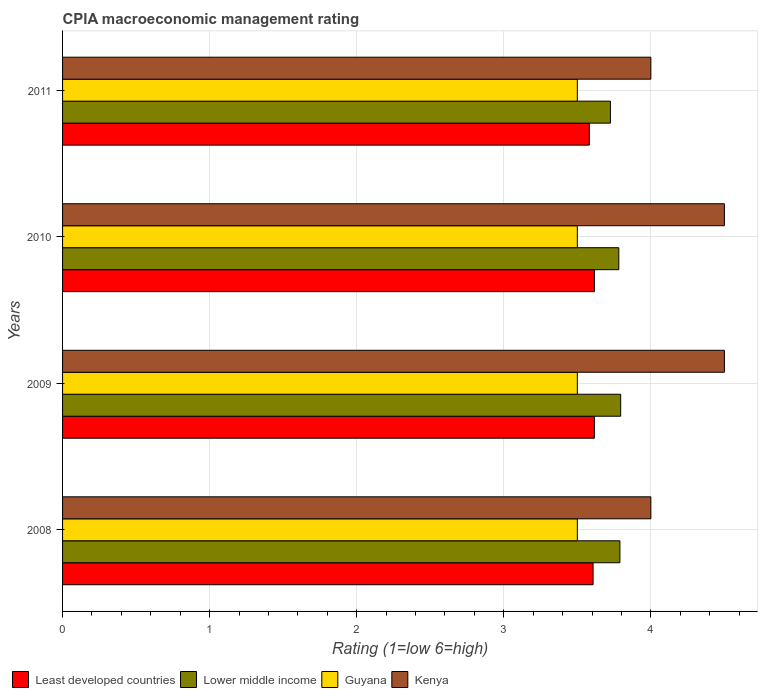Are the number of bars on each tick of the Y-axis equal?
Keep it short and to the point. Yes. How many bars are there on the 1st tick from the top?
Offer a very short reply. 4. How many bars are there on the 3rd tick from the bottom?
Your response must be concise. 4. In how many cases, is the number of bars for a given year not equal to the number of legend labels?
Make the answer very short. 0. What is the CPIA rating in Guyana in 2008?
Provide a short and direct response. 3.5. Across all years, what is the maximum CPIA rating in Lower middle income?
Your response must be concise. 3.79. Across all years, what is the minimum CPIA rating in Lower middle income?
Give a very brief answer. 3.73. In which year was the CPIA rating in Lower middle income minimum?
Your response must be concise. 2011. What is the difference between the CPIA rating in Lower middle income in 2009 and that in 2011?
Make the answer very short. 0.07. What is the difference between the CPIA rating in Least developed countries in 2009 and the CPIA rating in Lower middle income in 2008?
Offer a very short reply. -0.17. What is the average CPIA rating in Least developed countries per year?
Offer a very short reply. 3.61. In the year 2008, what is the difference between the CPIA rating in Guyana and CPIA rating in Least developed countries?
Your answer should be compact. -0.11. What is the ratio of the CPIA rating in Least developed countries in 2008 to that in 2011?
Your answer should be compact. 1.01. What is the difference between the highest and the second highest CPIA rating in Lower middle income?
Your answer should be very brief. 0.01. What is the difference between the highest and the lowest CPIA rating in Kenya?
Make the answer very short. 0.5. Is the sum of the CPIA rating in Kenya in 2009 and 2010 greater than the maximum CPIA rating in Guyana across all years?
Provide a succinct answer. Yes. Is it the case that in every year, the sum of the CPIA rating in Lower middle income and CPIA rating in Least developed countries is greater than the sum of CPIA rating in Kenya and CPIA rating in Guyana?
Make the answer very short. Yes. What does the 4th bar from the top in 2009 represents?
Your answer should be very brief. Least developed countries. What does the 1st bar from the bottom in 2008 represents?
Your answer should be very brief. Least developed countries. How many bars are there?
Keep it short and to the point. 16. What is the difference between two consecutive major ticks on the X-axis?
Your answer should be compact. 1. How many legend labels are there?
Make the answer very short. 4. How are the legend labels stacked?
Offer a terse response. Horizontal. What is the title of the graph?
Keep it short and to the point. CPIA macroeconomic management rating. What is the label or title of the X-axis?
Your answer should be very brief. Rating (1=low 6=high). What is the label or title of the Y-axis?
Your response must be concise. Years. What is the Rating (1=low 6=high) in Least developed countries in 2008?
Give a very brief answer. 3.61. What is the Rating (1=low 6=high) in Lower middle income in 2008?
Provide a short and direct response. 3.79. What is the Rating (1=low 6=high) of Least developed countries in 2009?
Keep it short and to the point. 3.62. What is the Rating (1=low 6=high) of Lower middle income in 2009?
Offer a very short reply. 3.79. What is the Rating (1=low 6=high) in Guyana in 2009?
Ensure brevity in your answer.  3.5. What is the Rating (1=low 6=high) in Least developed countries in 2010?
Give a very brief answer. 3.62. What is the Rating (1=low 6=high) in Lower middle income in 2010?
Your answer should be very brief. 3.78. What is the Rating (1=low 6=high) in Guyana in 2010?
Your answer should be very brief. 3.5. What is the Rating (1=low 6=high) of Kenya in 2010?
Offer a terse response. 4.5. What is the Rating (1=low 6=high) in Least developed countries in 2011?
Make the answer very short. 3.58. What is the Rating (1=low 6=high) of Lower middle income in 2011?
Make the answer very short. 3.73. What is the Rating (1=low 6=high) of Guyana in 2011?
Ensure brevity in your answer.  3.5. What is the Rating (1=low 6=high) of Kenya in 2011?
Make the answer very short. 4. Across all years, what is the maximum Rating (1=low 6=high) in Least developed countries?
Keep it short and to the point. 3.62. Across all years, what is the maximum Rating (1=low 6=high) of Lower middle income?
Provide a succinct answer. 3.79. Across all years, what is the maximum Rating (1=low 6=high) of Guyana?
Provide a short and direct response. 3.5. Across all years, what is the minimum Rating (1=low 6=high) of Least developed countries?
Offer a very short reply. 3.58. Across all years, what is the minimum Rating (1=low 6=high) in Lower middle income?
Your answer should be compact. 3.73. What is the total Rating (1=low 6=high) of Least developed countries in the graph?
Make the answer very short. 14.42. What is the total Rating (1=low 6=high) of Lower middle income in the graph?
Provide a succinct answer. 15.09. What is the difference between the Rating (1=low 6=high) in Least developed countries in 2008 and that in 2009?
Ensure brevity in your answer.  -0.01. What is the difference between the Rating (1=low 6=high) in Lower middle income in 2008 and that in 2009?
Your answer should be compact. -0.01. What is the difference between the Rating (1=low 6=high) of Guyana in 2008 and that in 2009?
Your answer should be compact. 0. What is the difference between the Rating (1=low 6=high) in Kenya in 2008 and that in 2009?
Give a very brief answer. -0.5. What is the difference between the Rating (1=low 6=high) in Least developed countries in 2008 and that in 2010?
Offer a terse response. -0.01. What is the difference between the Rating (1=low 6=high) of Lower middle income in 2008 and that in 2010?
Provide a short and direct response. 0.01. What is the difference between the Rating (1=low 6=high) of Least developed countries in 2008 and that in 2011?
Offer a terse response. 0.03. What is the difference between the Rating (1=low 6=high) of Lower middle income in 2008 and that in 2011?
Provide a succinct answer. 0.06. What is the difference between the Rating (1=low 6=high) of Least developed countries in 2009 and that in 2010?
Your response must be concise. 0. What is the difference between the Rating (1=low 6=high) of Lower middle income in 2009 and that in 2010?
Offer a very short reply. 0.01. What is the difference between the Rating (1=low 6=high) of Guyana in 2009 and that in 2010?
Ensure brevity in your answer.  0. What is the difference between the Rating (1=low 6=high) of Least developed countries in 2009 and that in 2011?
Your response must be concise. 0.03. What is the difference between the Rating (1=low 6=high) of Lower middle income in 2009 and that in 2011?
Give a very brief answer. 0.07. What is the difference between the Rating (1=low 6=high) of Guyana in 2009 and that in 2011?
Your answer should be very brief. 0. What is the difference between the Rating (1=low 6=high) of Kenya in 2009 and that in 2011?
Provide a short and direct response. 0.5. What is the difference between the Rating (1=low 6=high) in Least developed countries in 2010 and that in 2011?
Provide a succinct answer. 0.03. What is the difference between the Rating (1=low 6=high) of Lower middle income in 2010 and that in 2011?
Your answer should be very brief. 0.06. What is the difference between the Rating (1=low 6=high) of Kenya in 2010 and that in 2011?
Give a very brief answer. 0.5. What is the difference between the Rating (1=low 6=high) in Least developed countries in 2008 and the Rating (1=low 6=high) in Lower middle income in 2009?
Your answer should be very brief. -0.19. What is the difference between the Rating (1=low 6=high) of Least developed countries in 2008 and the Rating (1=low 6=high) of Guyana in 2009?
Your response must be concise. 0.11. What is the difference between the Rating (1=low 6=high) in Least developed countries in 2008 and the Rating (1=low 6=high) in Kenya in 2009?
Offer a terse response. -0.89. What is the difference between the Rating (1=low 6=high) in Lower middle income in 2008 and the Rating (1=low 6=high) in Guyana in 2009?
Your response must be concise. 0.29. What is the difference between the Rating (1=low 6=high) of Lower middle income in 2008 and the Rating (1=low 6=high) of Kenya in 2009?
Your answer should be compact. -0.71. What is the difference between the Rating (1=low 6=high) of Guyana in 2008 and the Rating (1=low 6=high) of Kenya in 2009?
Your response must be concise. -1. What is the difference between the Rating (1=low 6=high) of Least developed countries in 2008 and the Rating (1=low 6=high) of Lower middle income in 2010?
Give a very brief answer. -0.17. What is the difference between the Rating (1=low 6=high) of Least developed countries in 2008 and the Rating (1=low 6=high) of Guyana in 2010?
Offer a terse response. 0.11. What is the difference between the Rating (1=low 6=high) of Least developed countries in 2008 and the Rating (1=low 6=high) of Kenya in 2010?
Keep it short and to the point. -0.89. What is the difference between the Rating (1=low 6=high) of Lower middle income in 2008 and the Rating (1=low 6=high) of Guyana in 2010?
Keep it short and to the point. 0.29. What is the difference between the Rating (1=low 6=high) of Lower middle income in 2008 and the Rating (1=low 6=high) of Kenya in 2010?
Your response must be concise. -0.71. What is the difference between the Rating (1=low 6=high) of Guyana in 2008 and the Rating (1=low 6=high) of Kenya in 2010?
Your answer should be compact. -1. What is the difference between the Rating (1=low 6=high) of Least developed countries in 2008 and the Rating (1=low 6=high) of Lower middle income in 2011?
Provide a short and direct response. -0.12. What is the difference between the Rating (1=low 6=high) of Least developed countries in 2008 and the Rating (1=low 6=high) of Guyana in 2011?
Provide a short and direct response. 0.11. What is the difference between the Rating (1=low 6=high) in Least developed countries in 2008 and the Rating (1=low 6=high) in Kenya in 2011?
Offer a terse response. -0.39. What is the difference between the Rating (1=low 6=high) in Lower middle income in 2008 and the Rating (1=low 6=high) in Guyana in 2011?
Your response must be concise. 0.29. What is the difference between the Rating (1=low 6=high) of Lower middle income in 2008 and the Rating (1=low 6=high) of Kenya in 2011?
Ensure brevity in your answer.  -0.21. What is the difference between the Rating (1=low 6=high) of Least developed countries in 2009 and the Rating (1=low 6=high) of Lower middle income in 2010?
Your answer should be compact. -0.17. What is the difference between the Rating (1=low 6=high) in Least developed countries in 2009 and the Rating (1=low 6=high) in Guyana in 2010?
Ensure brevity in your answer.  0.12. What is the difference between the Rating (1=low 6=high) in Least developed countries in 2009 and the Rating (1=low 6=high) in Kenya in 2010?
Make the answer very short. -0.88. What is the difference between the Rating (1=low 6=high) of Lower middle income in 2009 and the Rating (1=low 6=high) of Guyana in 2010?
Give a very brief answer. 0.29. What is the difference between the Rating (1=low 6=high) of Lower middle income in 2009 and the Rating (1=low 6=high) of Kenya in 2010?
Keep it short and to the point. -0.71. What is the difference between the Rating (1=low 6=high) in Least developed countries in 2009 and the Rating (1=low 6=high) in Lower middle income in 2011?
Provide a short and direct response. -0.11. What is the difference between the Rating (1=low 6=high) of Least developed countries in 2009 and the Rating (1=low 6=high) of Guyana in 2011?
Offer a very short reply. 0.12. What is the difference between the Rating (1=low 6=high) of Least developed countries in 2009 and the Rating (1=low 6=high) of Kenya in 2011?
Your response must be concise. -0.38. What is the difference between the Rating (1=low 6=high) of Lower middle income in 2009 and the Rating (1=low 6=high) of Guyana in 2011?
Offer a very short reply. 0.29. What is the difference between the Rating (1=low 6=high) in Lower middle income in 2009 and the Rating (1=low 6=high) in Kenya in 2011?
Make the answer very short. -0.21. What is the difference between the Rating (1=low 6=high) in Guyana in 2009 and the Rating (1=low 6=high) in Kenya in 2011?
Your response must be concise. -0.5. What is the difference between the Rating (1=low 6=high) in Least developed countries in 2010 and the Rating (1=low 6=high) in Lower middle income in 2011?
Provide a succinct answer. -0.11. What is the difference between the Rating (1=low 6=high) of Least developed countries in 2010 and the Rating (1=low 6=high) of Guyana in 2011?
Offer a very short reply. 0.12. What is the difference between the Rating (1=low 6=high) in Least developed countries in 2010 and the Rating (1=low 6=high) in Kenya in 2011?
Provide a short and direct response. -0.38. What is the difference between the Rating (1=low 6=high) in Lower middle income in 2010 and the Rating (1=low 6=high) in Guyana in 2011?
Keep it short and to the point. 0.28. What is the difference between the Rating (1=low 6=high) in Lower middle income in 2010 and the Rating (1=low 6=high) in Kenya in 2011?
Give a very brief answer. -0.22. What is the difference between the Rating (1=low 6=high) of Guyana in 2010 and the Rating (1=low 6=high) of Kenya in 2011?
Offer a terse response. -0.5. What is the average Rating (1=low 6=high) of Least developed countries per year?
Provide a short and direct response. 3.61. What is the average Rating (1=low 6=high) of Lower middle income per year?
Offer a very short reply. 3.77. What is the average Rating (1=low 6=high) of Kenya per year?
Your response must be concise. 4.25. In the year 2008, what is the difference between the Rating (1=low 6=high) of Least developed countries and Rating (1=low 6=high) of Lower middle income?
Provide a short and direct response. -0.18. In the year 2008, what is the difference between the Rating (1=low 6=high) of Least developed countries and Rating (1=low 6=high) of Guyana?
Your answer should be compact. 0.11. In the year 2008, what is the difference between the Rating (1=low 6=high) in Least developed countries and Rating (1=low 6=high) in Kenya?
Give a very brief answer. -0.39. In the year 2008, what is the difference between the Rating (1=low 6=high) of Lower middle income and Rating (1=low 6=high) of Guyana?
Your answer should be very brief. 0.29. In the year 2008, what is the difference between the Rating (1=low 6=high) of Lower middle income and Rating (1=low 6=high) of Kenya?
Offer a terse response. -0.21. In the year 2008, what is the difference between the Rating (1=low 6=high) of Guyana and Rating (1=low 6=high) of Kenya?
Keep it short and to the point. -0.5. In the year 2009, what is the difference between the Rating (1=low 6=high) of Least developed countries and Rating (1=low 6=high) of Lower middle income?
Keep it short and to the point. -0.18. In the year 2009, what is the difference between the Rating (1=low 6=high) in Least developed countries and Rating (1=low 6=high) in Guyana?
Make the answer very short. 0.12. In the year 2009, what is the difference between the Rating (1=low 6=high) of Least developed countries and Rating (1=low 6=high) of Kenya?
Provide a short and direct response. -0.88. In the year 2009, what is the difference between the Rating (1=low 6=high) in Lower middle income and Rating (1=low 6=high) in Guyana?
Offer a very short reply. 0.29. In the year 2009, what is the difference between the Rating (1=low 6=high) of Lower middle income and Rating (1=low 6=high) of Kenya?
Your answer should be compact. -0.71. In the year 2010, what is the difference between the Rating (1=low 6=high) of Least developed countries and Rating (1=low 6=high) of Lower middle income?
Ensure brevity in your answer.  -0.17. In the year 2010, what is the difference between the Rating (1=low 6=high) in Least developed countries and Rating (1=low 6=high) in Guyana?
Provide a succinct answer. 0.12. In the year 2010, what is the difference between the Rating (1=low 6=high) in Least developed countries and Rating (1=low 6=high) in Kenya?
Your answer should be very brief. -0.88. In the year 2010, what is the difference between the Rating (1=low 6=high) in Lower middle income and Rating (1=low 6=high) in Guyana?
Offer a terse response. 0.28. In the year 2010, what is the difference between the Rating (1=low 6=high) of Lower middle income and Rating (1=low 6=high) of Kenya?
Offer a very short reply. -0.72. In the year 2010, what is the difference between the Rating (1=low 6=high) of Guyana and Rating (1=low 6=high) of Kenya?
Your response must be concise. -1. In the year 2011, what is the difference between the Rating (1=low 6=high) of Least developed countries and Rating (1=low 6=high) of Lower middle income?
Make the answer very short. -0.14. In the year 2011, what is the difference between the Rating (1=low 6=high) of Least developed countries and Rating (1=low 6=high) of Guyana?
Give a very brief answer. 0.08. In the year 2011, what is the difference between the Rating (1=low 6=high) in Least developed countries and Rating (1=low 6=high) in Kenya?
Keep it short and to the point. -0.42. In the year 2011, what is the difference between the Rating (1=low 6=high) of Lower middle income and Rating (1=low 6=high) of Guyana?
Offer a terse response. 0.23. In the year 2011, what is the difference between the Rating (1=low 6=high) of Lower middle income and Rating (1=low 6=high) of Kenya?
Offer a terse response. -0.28. In the year 2011, what is the difference between the Rating (1=low 6=high) in Guyana and Rating (1=low 6=high) in Kenya?
Provide a short and direct response. -0.5. What is the ratio of the Rating (1=low 6=high) in Least developed countries in 2008 to that in 2009?
Make the answer very short. 1. What is the ratio of the Rating (1=low 6=high) in Guyana in 2008 to that in 2009?
Keep it short and to the point. 1. What is the ratio of the Rating (1=low 6=high) in Kenya in 2008 to that in 2009?
Offer a very short reply. 0.89. What is the ratio of the Rating (1=low 6=high) in Lower middle income in 2008 to that in 2010?
Offer a terse response. 1. What is the ratio of the Rating (1=low 6=high) of Lower middle income in 2008 to that in 2011?
Make the answer very short. 1.02. What is the ratio of the Rating (1=low 6=high) of Guyana in 2008 to that in 2011?
Make the answer very short. 1. What is the ratio of the Rating (1=low 6=high) in Kenya in 2008 to that in 2011?
Keep it short and to the point. 1. What is the ratio of the Rating (1=low 6=high) of Least developed countries in 2009 to that in 2010?
Your answer should be compact. 1. What is the ratio of the Rating (1=low 6=high) of Guyana in 2009 to that in 2010?
Provide a short and direct response. 1. What is the ratio of the Rating (1=low 6=high) in Kenya in 2009 to that in 2010?
Make the answer very short. 1. What is the ratio of the Rating (1=low 6=high) of Least developed countries in 2009 to that in 2011?
Offer a very short reply. 1.01. What is the ratio of the Rating (1=low 6=high) of Lower middle income in 2009 to that in 2011?
Your answer should be very brief. 1.02. What is the ratio of the Rating (1=low 6=high) in Guyana in 2009 to that in 2011?
Give a very brief answer. 1. What is the ratio of the Rating (1=low 6=high) of Least developed countries in 2010 to that in 2011?
Ensure brevity in your answer.  1.01. What is the ratio of the Rating (1=low 6=high) in Lower middle income in 2010 to that in 2011?
Provide a succinct answer. 1.02. What is the ratio of the Rating (1=low 6=high) of Guyana in 2010 to that in 2011?
Provide a succinct answer. 1. What is the difference between the highest and the second highest Rating (1=low 6=high) of Least developed countries?
Ensure brevity in your answer.  0. What is the difference between the highest and the second highest Rating (1=low 6=high) of Lower middle income?
Make the answer very short. 0.01. What is the difference between the highest and the second highest Rating (1=low 6=high) in Guyana?
Your answer should be very brief. 0. What is the difference between the highest and the second highest Rating (1=low 6=high) of Kenya?
Give a very brief answer. 0. What is the difference between the highest and the lowest Rating (1=low 6=high) of Least developed countries?
Provide a succinct answer. 0.03. What is the difference between the highest and the lowest Rating (1=low 6=high) in Lower middle income?
Give a very brief answer. 0.07. What is the difference between the highest and the lowest Rating (1=low 6=high) of Guyana?
Your response must be concise. 0. 